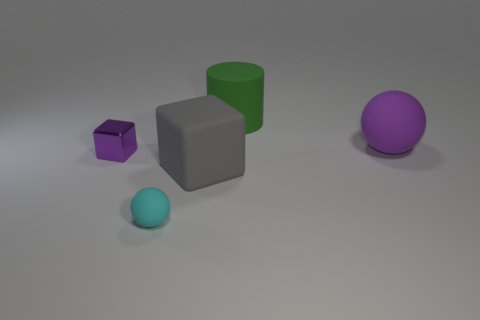The big object that is the same color as the tiny cube is what shape?
Provide a succinct answer. Sphere. What number of other things are there of the same shape as the metal object?
Provide a short and direct response. 1. What number of green things are either rubber objects or rubber cylinders?
Provide a succinct answer. 1. There is a small sphere that is made of the same material as the cylinder; what color is it?
Your answer should be compact. Cyan. Is the material of the ball that is in front of the purple matte sphere the same as the purple thing to the left of the green matte thing?
Make the answer very short. No. The other thing that is the same color as the shiny object is what size?
Provide a short and direct response. Large. There is a block in front of the tiny shiny thing; what material is it?
Make the answer very short. Rubber. There is a big object that is in front of the purple shiny object; is it the same shape as the thing on the right side of the large green matte cylinder?
Provide a succinct answer. No. There is a ball that is the same color as the metal block; what material is it?
Provide a succinct answer. Rubber. Are any large brown blocks visible?
Your answer should be compact. No. 